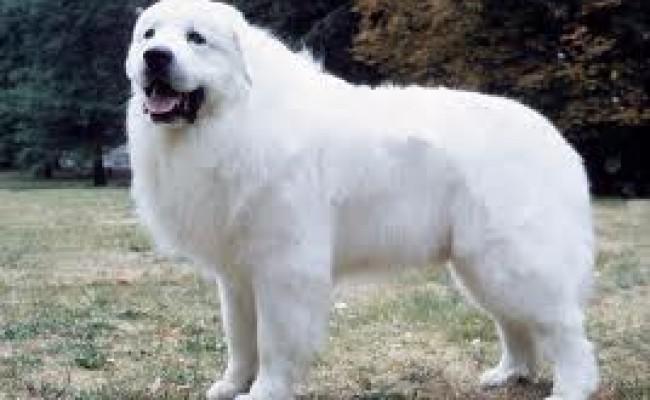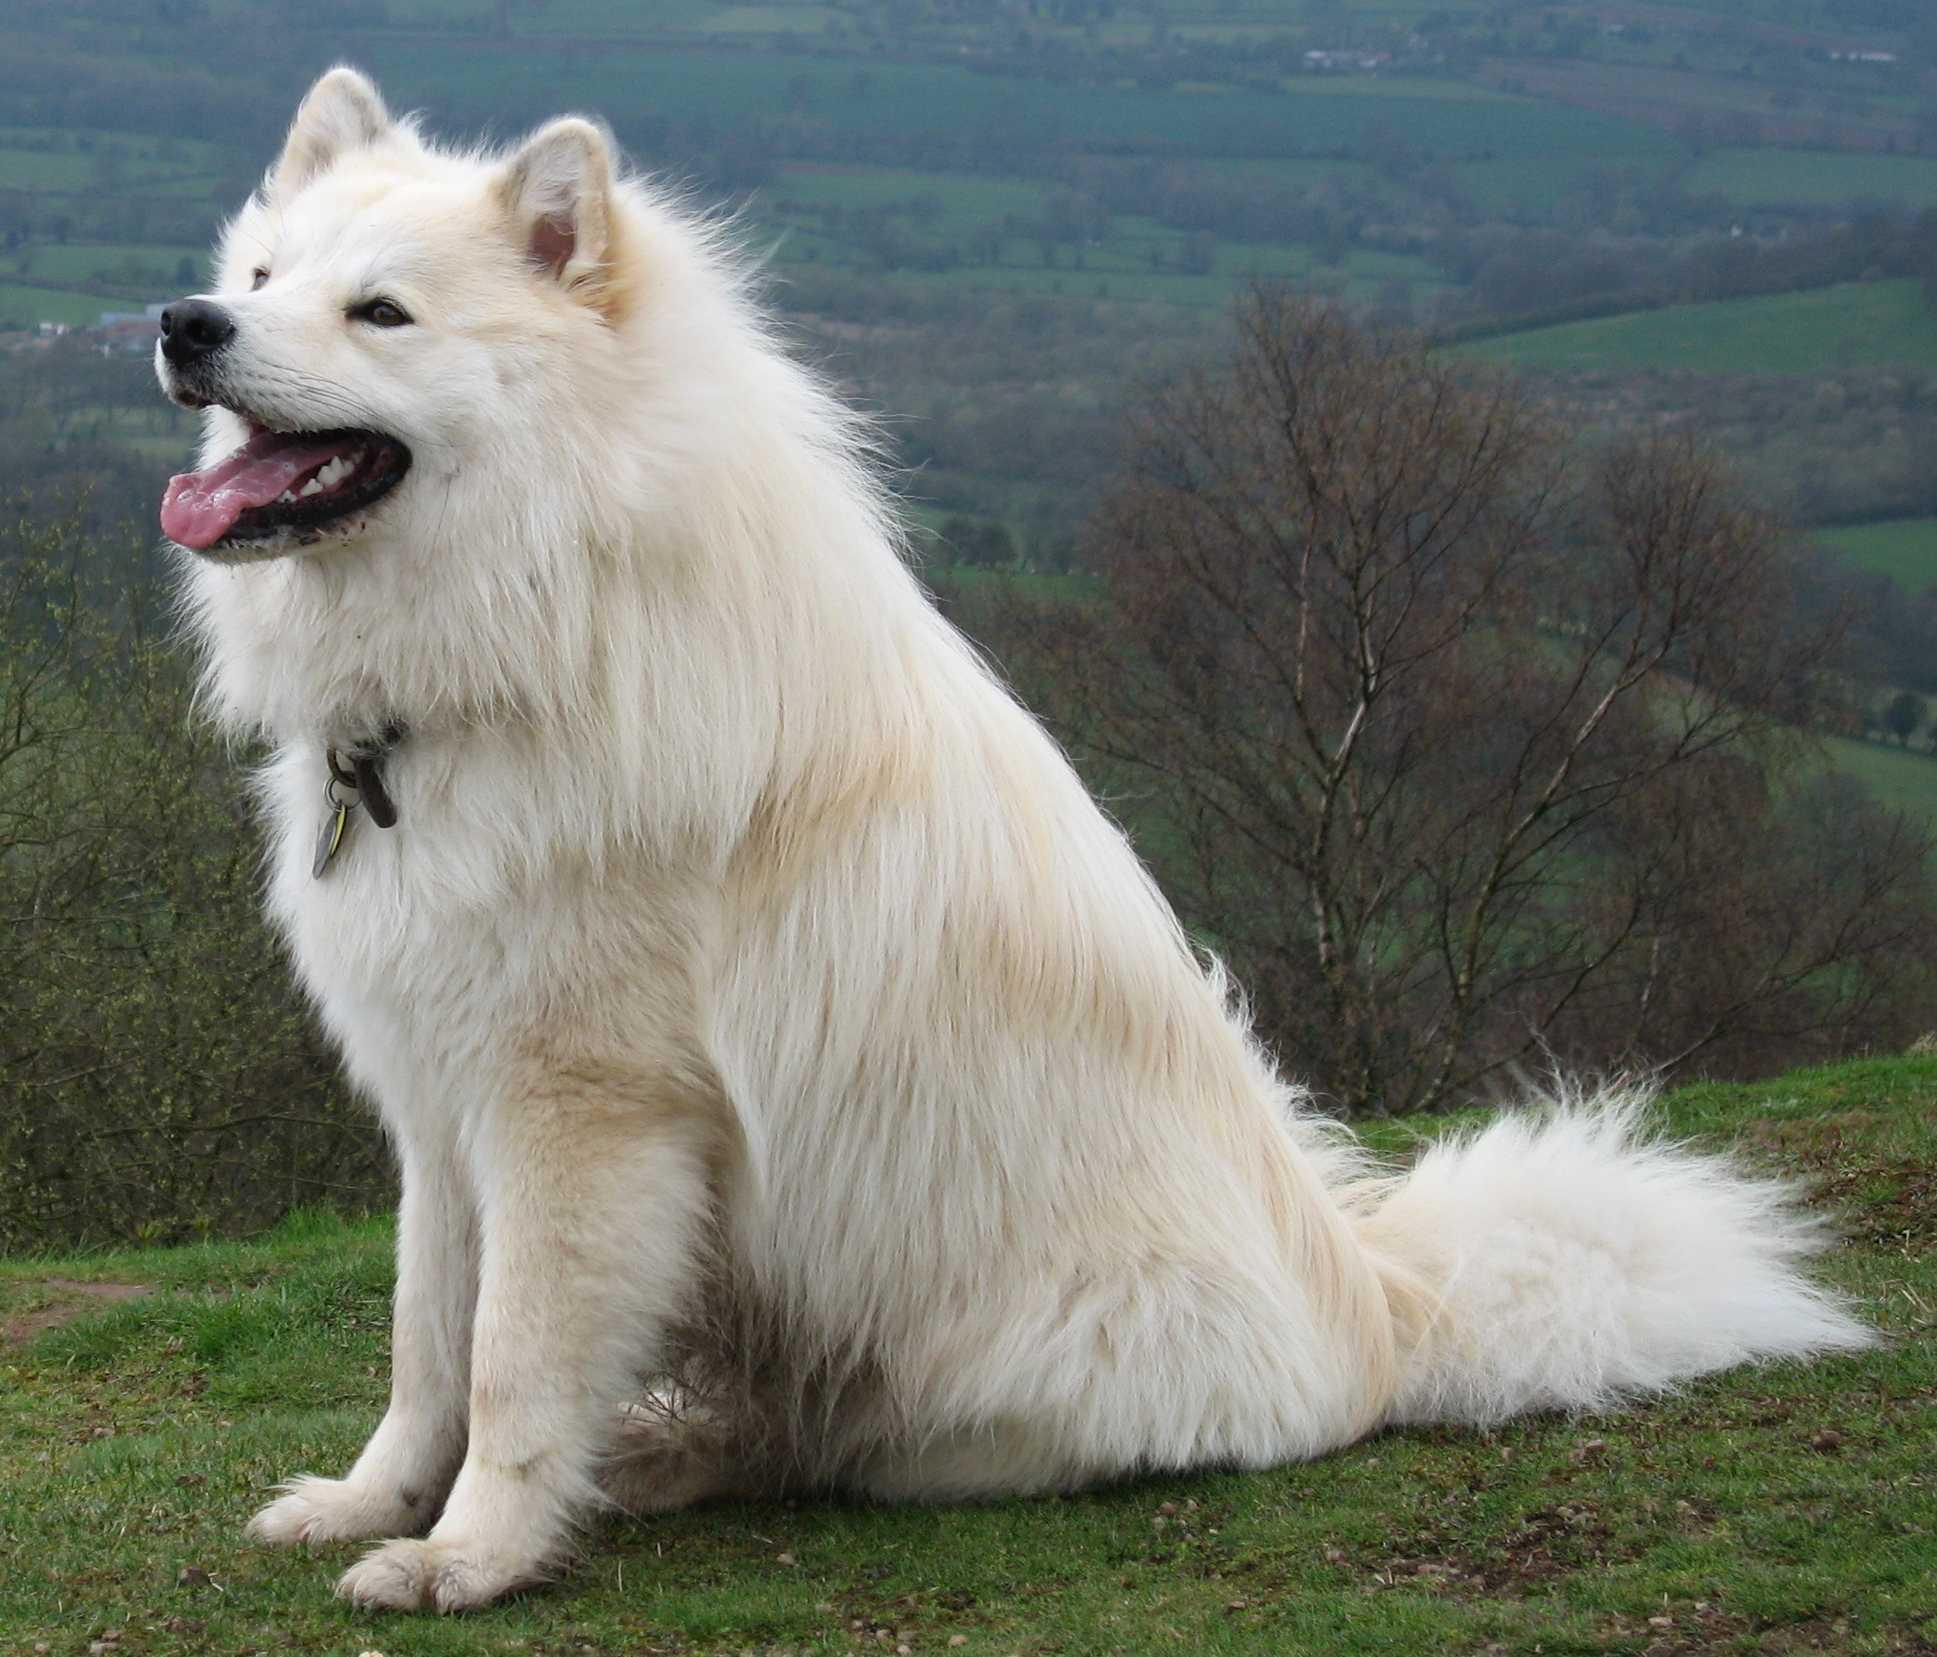The first image is the image on the left, the second image is the image on the right. For the images displayed, is the sentence "The dog is interacting with a human in one picture." factually correct? Answer yes or no. No. 